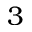Convert formula to latex. <formula><loc_0><loc_0><loc_500><loc_500>3</formula> 